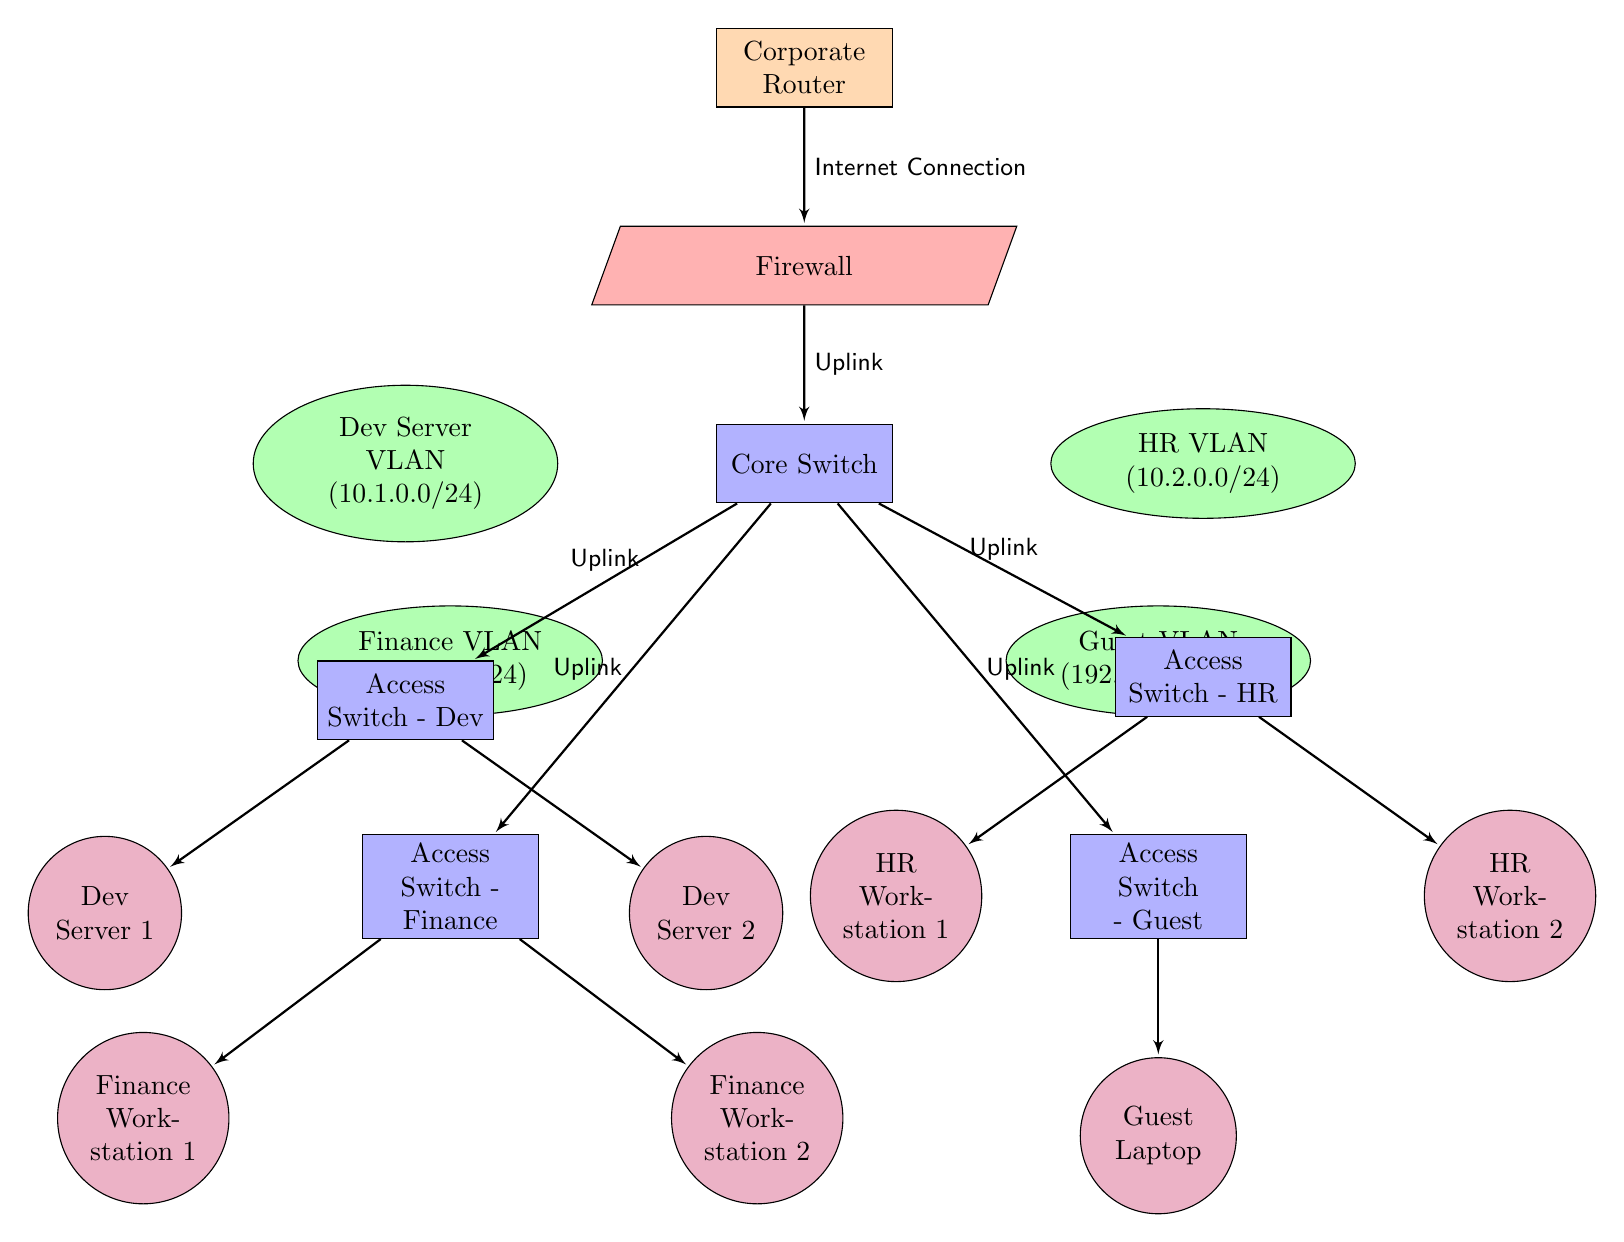What are the IP ranges for the Dev Server VLAN? The diagram indicates that the IP range for the Dev Server VLAN is explicitly labeled as 10.1.0.0/24.
Answer: 10.1.0.0/24 How many access switches are present in the diagram? By counting the access switches depicted in the diagram, we find four labeled: Access Switch - Dev, Access Switch - HR, Access Switch - Finance, and Access Switch - Guest, which totals to four.
Answer: 4 What device is connected to the HR access switch? According to the diagram, the two devices connected to the Access Switch - HR are HR Workstation 1 and HR Workstation 2. Both devices are directly connected to this switch.
Answer: HR Workstation 1, HR Workstation 2 Which VLAN has the IP range of 192.168.1.0/24? The Guest VLAN is specified in the diagram with the IP range of 192.168.1.0/24, as shown under the VLANs section.
Answer: Guest VLAN What is the primary connection between the Corporate Router and the Firewall? The diagram shows a connection labeled as "Internet Connection" leading directly from the Corporate Router to the Firewall, indicating its primary purpose.
Answer: Internet Connection Which switch connects to the Finance VLAN? The diagram illustrates that the Access Switch - Finance connects to the Finance VLAN, as indicated by the connection and placement in the diagram.
Answer: Access Switch - Finance How many devices are connected to the Dev Server VLAN? The diagram specifies that two devices, labeled as Dev Server 1 and Dev Server 2, are connected to the Access Switch - Dev, which connects to the Dev Server VLAN, totaling to two devices.
Answer: 2 What type of device is the Core Switch? The Core Switch is represented as a blue rectangle in the diagram, which indicates that it is classified as a switch, fulfilling its role in this corporate LAN design.
Answer: Switch How is the Core Switch connected to the Access Switches? The diagram depicts that the Core Switch connects to each of the four Access Switches through individual "Uplink" connections, indicating its central role in network traffic distribution.
Answer: Uplink 